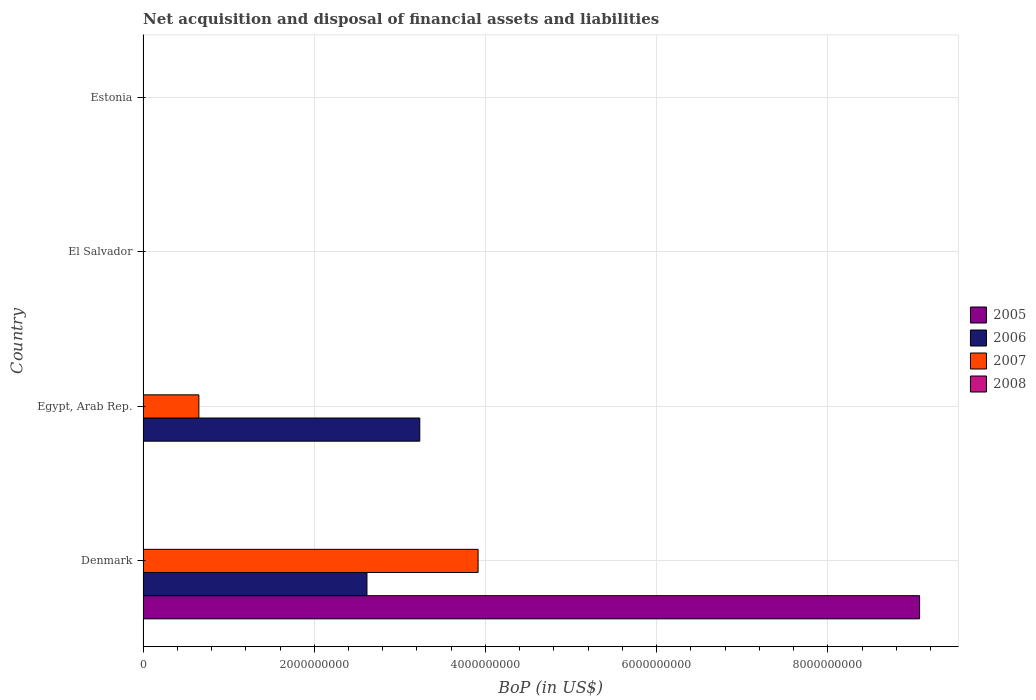How many different coloured bars are there?
Ensure brevity in your answer.  3. Are the number of bars per tick equal to the number of legend labels?
Give a very brief answer. No. Are the number of bars on each tick of the Y-axis equal?
Your answer should be very brief. No. How many bars are there on the 2nd tick from the bottom?
Your answer should be compact. 2. Across all countries, what is the maximum Balance of Payments in 2005?
Keep it short and to the point. 9.07e+09. Across all countries, what is the minimum Balance of Payments in 2008?
Offer a very short reply. 0. In which country was the Balance of Payments in 2006 maximum?
Your answer should be compact. Egypt, Arab Rep. What is the total Balance of Payments in 2006 in the graph?
Give a very brief answer. 5.85e+09. What is the difference between the Balance of Payments in 2007 in Denmark and that in Egypt, Arab Rep.?
Your answer should be compact. 3.26e+09. What is the difference between the Balance of Payments in 2006 in Egypt, Arab Rep. and the Balance of Payments in 2007 in Denmark?
Your response must be concise. -6.81e+08. What is the average Balance of Payments in 2005 per country?
Make the answer very short. 2.27e+09. What is the difference between the Balance of Payments in 2005 and Balance of Payments in 2006 in Denmark?
Keep it short and to the point. 6.46e+09. In how many countries, is the Balance of Payments in 2006 greater than 6000000000 US$?
Your response must be concise. 0. What is the difference between the highest and the lowest Balance of Payments in 2006?
Your answer should be very brief. 3.23e+09. In how many countries, is the Balance of Payments in 2005 greater than the average Balance of Payments in 2005 taken over all countries?
Give a very brief answer. 1. Is it the case that in every country, the sum of the Balance of Payments in 2006 and Balance of Payments in 2008 is greater than the Balance of Payments in 2005?
Make the answer very short. No. How many bars are there?
Provide a succinct answer. 5. Are all the bars in the graph horizontal?
Your answer should be compact. Yes. How many countries are there in the graph?
Your response must be concise. 4. What is the difference between two consecutive major ticks on the X-axis?
Your answer should be compact. 2.00e+09. Does the graph contain grids?
Provide a succinct answer. Yes. What is the title of the graph?
Provide a short and direct response. Net acquisition and disposal of financial assets and liabilities. Does "2010" appear as one of the legend labels in the graph?
Offer a terse response. No. What is the label or title of the X-axis?
Give a very brief answer. BoP (in US$). What is the BoP (in US$) in 2005 in Denmark?
Your response must be concise. 9.07e+09. What is the BoP (in US$) in 2006 in Denmark?
Make the answer very short. 2.62e+09. What is the BoP (in US$) of 2007 in Denmark?
Your answer should be very brief. 3.91e+09. What is the BoP (in US$) of 2006 in Egypt, Arab Rep.?
Your answer should be compact. 3.23e+09. What is the BoP (in US$) in 2007 in Egypt, Arab Rep.?
Keep it short and to the point. 6.52e+08. What is the BoP (in US$) in 2008 in Egypt, Arab Rep.?
Offer a terse response. 0. What is the BoP (in US$) in 2007 in El Salvador?
Give a very brief answer. 0. What is the BoP (in US$) in 2008 in El Salvador?
Make the answer very short. 0. What is the BoP (in US$) in 2005 in Estonia?
Your answer should be very brief. 0. What is the BoP (in US$) of 2006 in Estonia?
Offer a very short reply. 0. What is the BoP (in US$) in 2007 in Estonia?
Make the answer very short. 0. Across all countries, what is the maximum BoP (in US$) of 2005?
Provide a succinct answer. 9.07e+09. Across all countries, what is the maximum BoP (in US$) of 2006?
Provide a short and direct response. 3.23e+09. Across all countries, what is the maximum BoP (in US$) in 2007?
Make the answer very short. 3.91e+09. Across all countries, what is the minimum BoP (in US$) of 2005?
Your answer should be very brief. 0. Across all countries, what is the minimum BoP (in US$) of 2006?
Ensure brevity in your answer.  0. What is the total BoP (in US$) in 2005 in the graph?
Give a very brief answer. 9.07e+09. What is the total BoP (in US$) of 2006 in the graph?
Make the answer very short. 5.85e+09. What is the total BoP (in US$) in 2007 in the graph?
Ensure brevity in your answer.  4.57e+09. What is the total BoP (in US$) of 2008 in the graph?
Keep it short and to the point. 0. What is the difference between the BoP (in US$) in 2006 in Denmark and that in Egypt, Arab Rep.?
Keep it short and to the point. -6.17e+08. What is the difference between the BoP (in US$) of 2007 in Denmark and that in Egypt, Arab Rep.?
Give a very brief answer. 3.26e+09. What is the difference between the BoP (in US$) of 2005 in Denmark and the BoP (in US$) of 2006 in Egypt, Arab Rep.?
Provide a succinct answer. 5.84e+09. What is the difference between the BoP (in US$) in 2005 in Denmark and the BoP (in US$) in 2007 in Egypt, Arab Rep.?
Provide a succinct answer. 8.42e+09. What is the difference between the BoP (in US$) in 2006 in Denmark and the BoP (in US$) in 2007 in Egypt, Arab Rep.?
Provide a short and direct response. 1.96e+09. What is the average BoP (in US$) in 2005 per country?
Provide a succinct answer. 2.27e+09. What is the average BoP (in US$) in 2006 per country?
Provide a short and direct response. 1.46e+09. What is the average BoP (in US$) in 2007 per country?
Your response must be concise. 1.14e+09. What is the difference between the BoP (in US$) in 2005 and BoP (in US$) in 2006 in Denmark?
Provide a succinct answer. 6.46e+09. What is the difference between the BoP (in US$) in 2005 and BoP (in US$) in 2007 in Denmark?
Your answer should be compact. 5.16e+09. What is the difference between the BoP (in US$) in 2006 and BoP (in US$) in 2007 in Denmark?
Provide a short and direct response. -1.30e+09. What is the difference between the BoP (in US$) in 2006 and BoP (in US$) in 2007 in Egypt, Arab Rep.?
Give a very brief answer. 2.58e+09. What is the ratio of the BoP (in US$) in 2006 in Denmark to that in Egypt, Arab Rep.?
Make the answer very short. 0.81. What is the ratio of the BoP (in US$) of 2007 in Denmark to that in Egypt, Arab Rep.?
Make the answer very short. 6. What is the difference between the highest and the lowest BoP (in US$) of 2005?
Provide a succinct answer. 9.07e+09. What is the difference between the highest and the lowest BoP (in US$) in 2006?
Offer a terse response. 3.23e+09. What is the difference between the highest and the lowest BoP (in US$) in 2007?
Your response must be concise. 3.91e+09. 